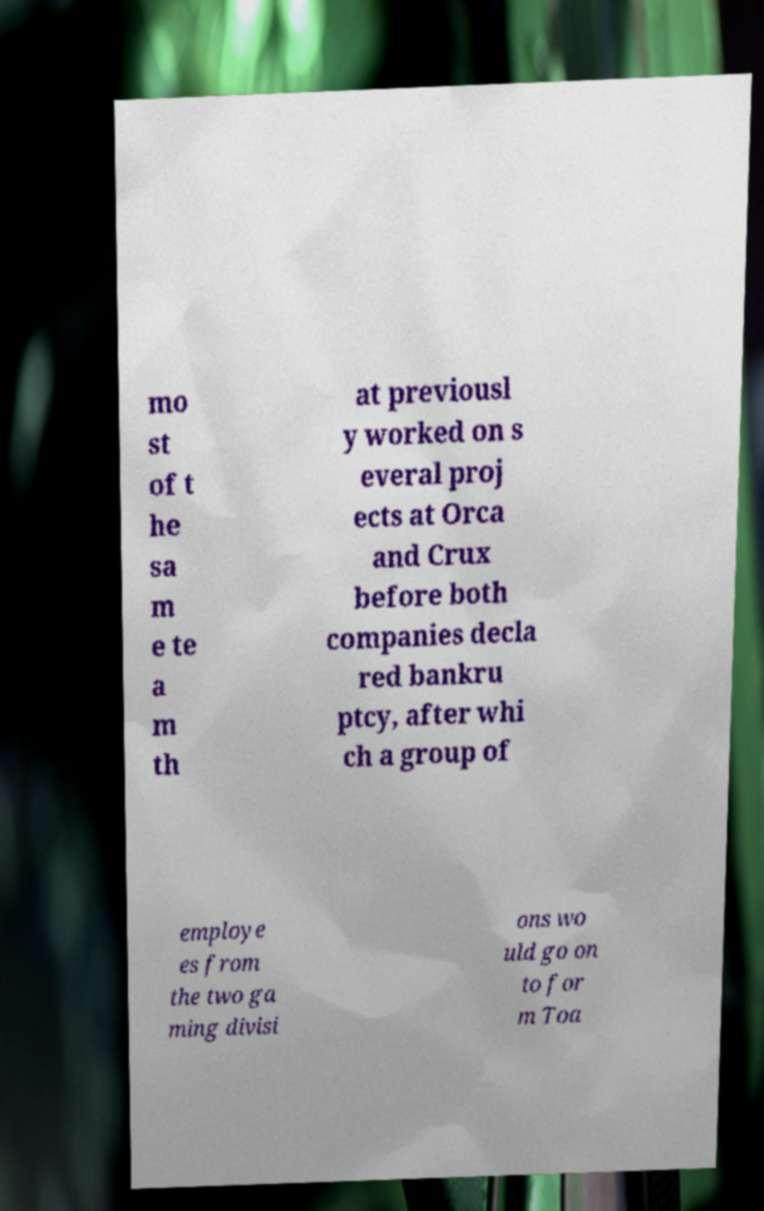Please identify and transcribe the text found in this image. mo st of t he sa m e te a m th at previousl y worked on s everal proj ects at Orca and Crux before both companies decla red bankru ptcy, after whi ch a group of employe es from the two ga ming divisi ons wo uld go on to for m Toa 